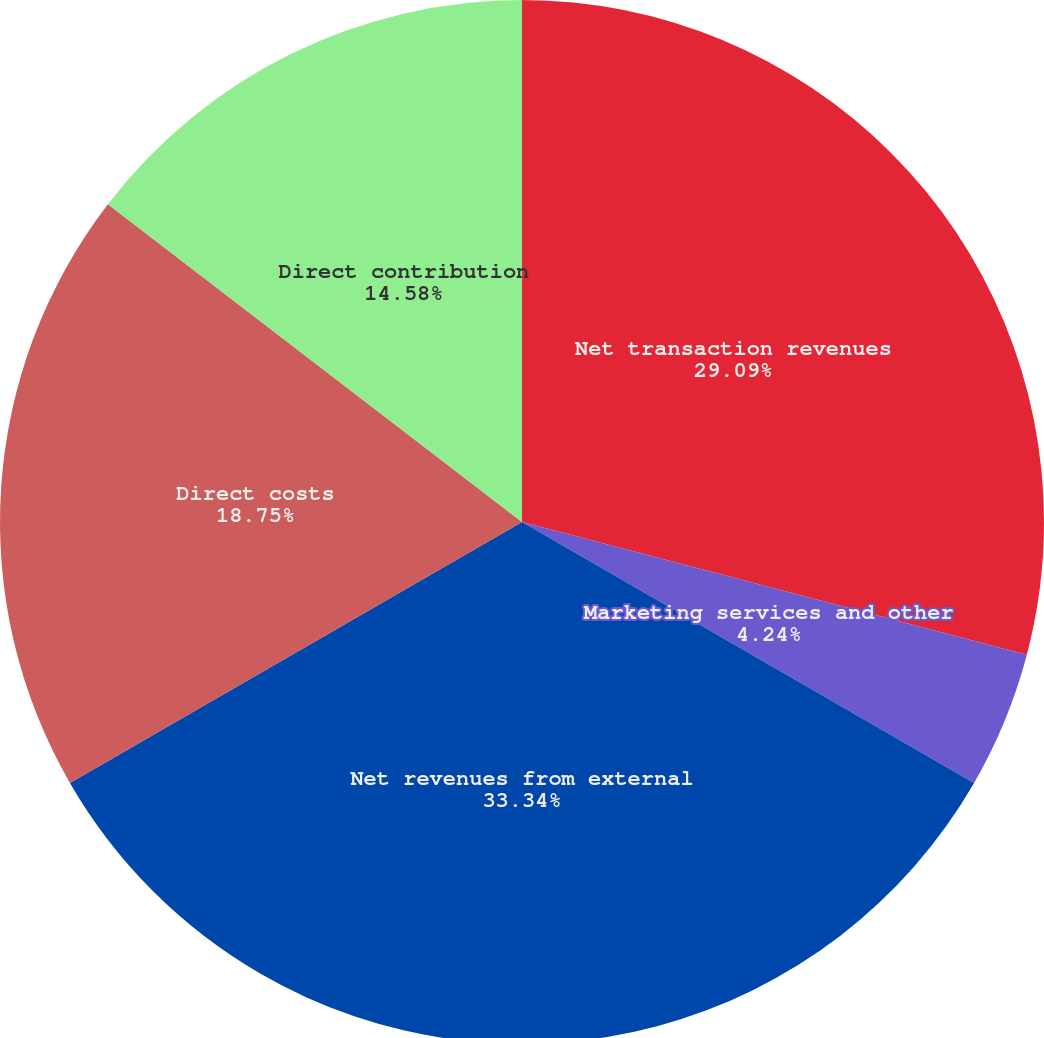Convert chart to OTSL. <chart><loc_0><loc_0><loc_500><loc_500><pie_chart><fcel>Net transaction revenues<fcel>Marketing services and other<fcel>Net revenues from external<fcel>Direct costs<fcel>Direct contribution<nl><fcel>29.09%<fcel>4.24%<fcel>33.33%<fcel>18.75%<fcel>14.58%<nl></chart> 